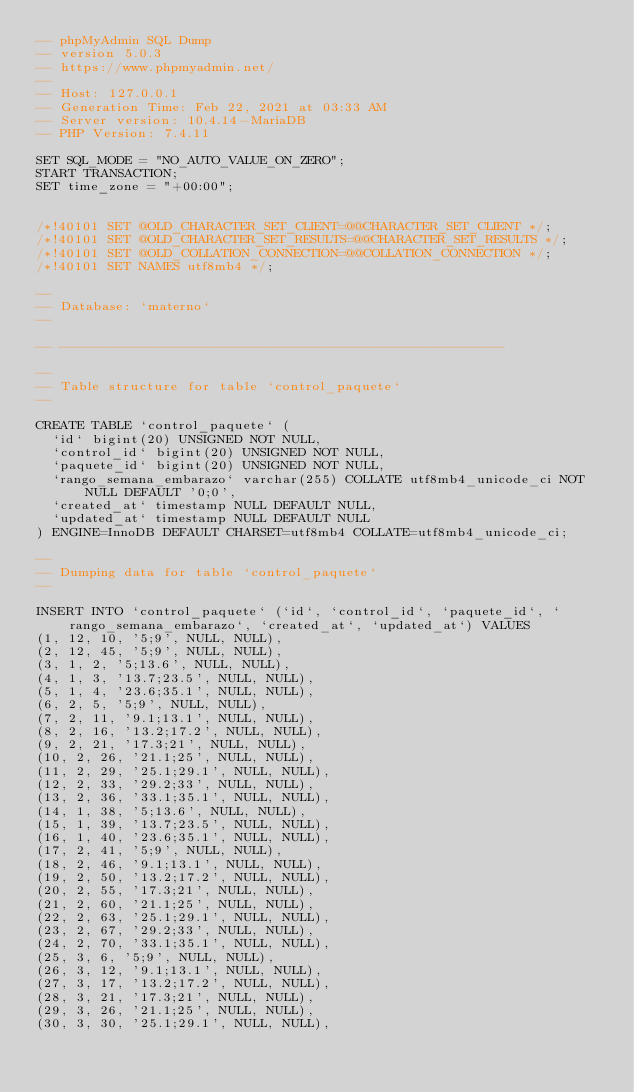<code> <loc_0><loc_0><loc_500><loc_500><_SQL_>-- phpMyAdmin SQL Dump
-- version 5.0.3
-- https://www.phpmyadmin.net/
--
-- Host: 127.0.0.1
-- Generation Time: Feb 22, 2021 at 03:33 AM
-- Server version: 10.4.14-MariaDB
-- PHP Version: 7.4.11

SET SQL_MODE = "NO_AUTO_VALUE_ON_ZERO";
START TRANSACTION;
SET time_zone = "+00:00";


/*!40101 SET @OLD_CHARACTER_SET_CLIENT=@@CHARACTER_SET_CLIENT */;
/*!40101 SET @OLD_CHARACTER_SET_RESULTS=@@CHARACTER_SET_RESULTS */;
/*!40101 SET @OLD_COLLATION_CONNECTION=@@COLLATION_CONNECTION */;
/*!40101 SET NAMES utf8mb4 */;

--
-- Database: `materno`
--

-- --------------------------------------------------------

--
-- Table structure for table `control_paquete`
--

CREATE TABLE `control_paquete` (
  `id` bigint(20) UNSIGNED NOT NULL,
  `control_id` bigint(20) UNSIGNED NOT NULL,
  `paquete_id` bigint(20) UNSIGNED NOT NULL,
  `rango_semana_embarazo` varchar(255) COLLATE utf8mb4_unicode_ci NOT NULL DEFAULT '0;0',
  `created_at` timestamp NULL DEFAULT NULL,
  `updated_at` timestamp NULL DEFAULT NULL
) ENGINE=InnoDB DEFAULT CHARSET=utf8mb4 COLLATE=utf8mb4_unicode_ci;

--
-- Dumping data for table `control_paquete`
--

INSERT INTO `control_paquete` (`id`, `control_id`, `paquete_id`, `rango_semana_embarazo`, `created_at`, `updated_at`) VALUES
(1, 12, 10, '5;9', NULL, NULL),
(2, 12, 45, '5;9', NULL, NULL),
(3, 1, 2, '5;13.6', NULL, NULL),
(4, 1, 3, '13.7;23.5', NULL, NULL),
(5, 1, 4, '23.6;35.1', NULL, NULL),
(6, 2, 5, '5;9', NULL, NULL),
(7, 2, 11, '9.1;13.1', NULL, NULL),
(8, 2, 16, '13.2;17.2', NULL, NULL),
(9, 2, 21, '17.3;21', NULL, NULL),
(10, 2, 26, '21.1;25', NULL, NULL),
(11, 2, 29, '25.1;29.1', NULL, NULL),
(12, 2, 33, '29.2;33', NULL, NULL),
(13, 2, 36, '33.1;35.1', NULL, NULL),
(14, 1, 38, '5;13.6', NULL, NULL),
(15, 1, 39, '13.7;23.5', NULL, NULL),
(16, 1, 40, '23.6;35.1', NULL, NULL),
(17, 2, 41, '5;9', NULL, NULL),
(18, 2, 46, '9.1;13.1', NULL, NULL),
(19, 2, 50, '13.2;17.2', NULL, NULL),
(20, 2, 55, '17.3;21', NULL, NULL),
(21, 2, 60, '21.1;25', NULL, NULL),
(22, 2, 63, '25.1;29.1', NULL, NULL),
(23, 2, 67, '29.2;33', NULL, NULL),
(24, 2, 70, '33.1;35.1', NULL, NULL),
(25, 3, 6, '5;9', NULL, NULL),
(26, 3, 12, '9.1;13.1', NULL, NULL),
(27, 3, 17, '13.2;17.2', NULL, NULL),
(28, 3, 21, '17.3;21', NULL, NULL),
(29, 3, 26, '21.1;25', NULL, NULL),
(30, 3, 30, '25.1;29.1', NULL, NULL),</code> 